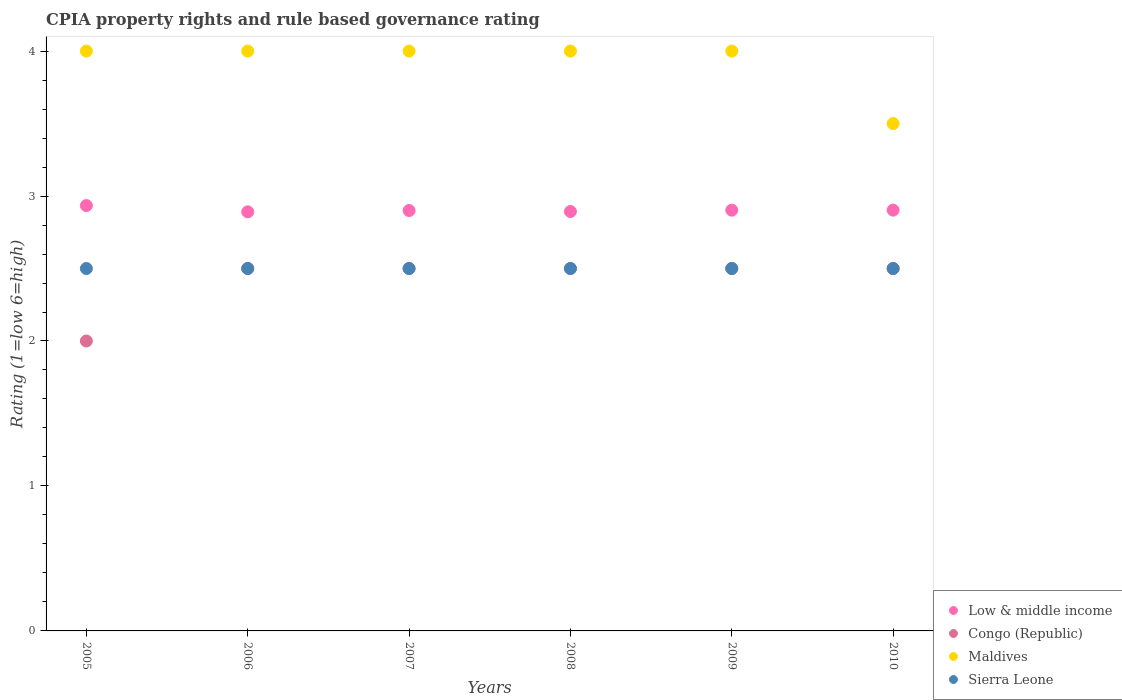How many different coloured dotlines are there?
Give a very brief answer. 4. Is the number of dotlines equal to the number of legend labels?
Provide a short and direct response. Yes. What is the CPIA rating in Sierra Leone in 2009?
Your response must be concise. 2.5. Across all years, what is the maximum CPIA rating in Low & middle income?
Your response must be concise. 2.93. Across all years, what is the minimum CPIA rating in Sierra Leone?
Provide a short and direct response. 2.5. In which year was the CPIA rating in Congo (Republic) maximum?
Your response must be concise. 2006. In which year was the CPIA rating in Low & middle income minimum?
Provide a succinct answer. 2006. What is the total CPIA rating in Low & middle income in the graph?
Make the answer very short. 17.42. What is the difference between the CPIA rating in Low & middle income in 2007 and that in 2008?
Provide a succinct answer. 0.01. What is the difference between the CPIA rating in Sierra Leone in 2009 and the CPIA rating in Maldives in 2008?
Keep it short and to the point. -1.5. What is the average CPIA rating in Congo (Republic) per year?
Your response must be concise. 2.42. In the year 2007, what is the difference between the CPIA rating in Sierra Leone and CPIA rating in Congo (Republic)?
Provide a short and direct response. 0. In how many years, is the CPIA rating in Low & middle income greater than 0.4?
Your answer should be very brief. 6. What is the ratio of the CPIA rating in Maldives in 2008 to that in 2010?
Your answer should be compact. 1.14. What is the difference between the highest and the second highest CPIA rating in Low & middle income?
Offer a terse response. 0.03. Is the sum of the CPIA rating in Maldives in 2006 and 2008 greater than the maximum CPIA rating in Low & middle income across all years?
Offer a very short reply. Yes. Is it the case that in every year, the sum of the CPIA rating in Low & middle income and CPIA rating in Congo (Republic)  is greater than the sum of CPIA rating in Maldives and CPIA rating in Sierra Leone?
Make the answer very short. No. Does the CPIA rating in Sierra Leone monotonically increase over the years?
Your answer should be compact. No. Is the CPIA rating in Maldives strictly less than the CPIA rating in Sierra Leone over the years?
Offer a terse response. No. How many dotlines are there?
Offer a very short reply. 4. What is the difference between two consecutive major ticks on the Y-axis?
Offer a very short reply. 1. Are the values on the major ticks of Y-axis written in scientific E-notation?
Provide a short and direct response. No. How many legend labels are there?
Provide a short and direct response. 4. What is the title of the graph?
Offer a very short reply. CPIA property rights and rule based governance rating. Does "Korea (Democratic)" appear as one of the legend labels in the graph?
Ensure brevity in your answer.  No. What is the Rating (1=low 6=high) of Low & middle income in 2005?
Make the answer very short. 2.93. What is the Rating (1=low 6=high) of Congo (Republic) in 2005?
Your answer should be very brief. 2. What is the Rating (1=low 6=high) of Low & middle income in 2006?
Your answer should be very brief. 2.89. What is the Rating (1=low 6=high) in Congo (Republic) in 2006?
Provide a succinct answer. 2.5. What is the Rating (1=low 6=high) in Sierra Leone in 2006?
Give a very brief answer. 2.5. What is the Rating (1=low 6=high) in Congo (Republic) in 2007?
Ensure brevity in your answer.  2.5. What is the Rating (1=low 6=high) in Maldives in 2007?
Your answer should be very brief. 4. What is the Rating (1=low 6=high) of Sierra Leone in 2007?
Provide a succinct answer. 2.5. What is the Rating (1=low 6=high) of Low & middle income in 2008?
Your answer should be compact. 2.89. What is the Rating (1=low 6=high) of Congo (Republic) in 2008?
Provide a succinct answer. 2.5. What is the Rating (1=low 6=high) of Maldives in 2008?
Offer a terse response. 4. What is the Rating (1=low 6=high) of Sierra Leone in 2008?
Ensure brevity in your answer.  2.5. What is the Rating (1=low 6=high) in Low & middle income in 2009?
Give a very brief answer. 2.9. What is the Rating (1=low 6=high) in Congo (Republic) in 2009?
Offer a terse response. 2.5. What is the Rating (1=low 6=high) in Low & middle income in 2010?
Provide a short and direct response. 2.9. What is the Rating (1=low 6=high) of Congo (Republic) in 2010?
Give a very brief answer. 2.5. What is the Rating (1=low 6=high) in Sierra Leone in 2010?
Give a very brief answer. 2.5. Across all years, what is the maximum Rating (1=low 6=high) of Low & middle income?
Provide a succinct answer. 2.93. Across all years, what is the maximum Rating (1=low 6=high) in Congo (Republic)?
Your answer should be compact. 2.5. Across all years, what is the maximum Rating (1=low 6=high) of Sierra Leone?
Your answer should be very brief. 2.5. Across all years, what is the minimum Rating (1=low 6=high) in Low & middle income?
Provide a short and direct response. 2.89. What is the total Rating (1=low 6=high) in Low & middle income in the graph?
Your response must be concise. 17.42. What is the total Rating (1=low 6=high) of Congo (Republic) in the graph?
Offer a very short reply. 14.5. What is the total Rating (1=low 6=high) of Sierra Leone in the graph?
Give a very brief answer. 15. What is the difference between the Rating (1=low 6=high) of Low & middle income in 2005 and that in 2006?
Your answer should be compact. 0.04. What is the difference between the Rating (1=low 6=high) of Congo (Republic) in 2005 and that in 2006?
Ensure brevity in your answer.  -0.5. What is the difference between the Rating (1=low 6=high) in Low & middle income in 2005 and that in 2007?
Ensure brevity in your answer.  0.03. What is the difference between the Rating (1=low 6=high) of Maldives in 2005 and that in 2007?
Offer a terse response. 0. What is the difference between the Rating (1=low 6=high) of Low & middle income in 2005 and that in 2008?
Provide a short and direct response. 0.04. What is the difference between the Rating (1=low 6=high) of Maldives in 2005 and that in 2008?
Provide a short and direct response. 0. What is the difference between the Rating (1=low 6=high) in Low & middle income in 2005 and that in 2009?
Your answer should be compact. 0.03. What is the difference between the Rating (1=low 6=high) of Maldives in 2005 and that in 2009?
Provide a short and direct response. 0. What is the difference between the Rating (1=low 6=high) in Low & middle income in 2005 and that in 2010?
Keep it short and to the point. 0.03. What is the difference between the Rating (1=low 6=high) in Sierra Leone in 2005 and that in 2010?
Your answer should be compact. 0. What is the difference between the Rating (1=low 6=high) of Low & middle income in 2006 and that in 2007?
Your answer should be very brief. -0.01. What is the difference between the Rating (1=low 6=high) in Sierra Leone in 2006 and that in 2007?
Provide a short and direct response. 0. What is the difference between the Rating (1=low 6=high) of Low & middle income in 2006 and that in 2008?
Your response must be concise. -0. What is the difference between the Rating (1=low 6=high) in Congo (Republic) in 2006 and that in 2008?
Your answer should be compact. 0. What is the difference between the Rating (1=low 6=high) of Low & middle income in 2006 and that in 2009?
Your answer should be very brief. -0.01. What is the difference between the Rating (1=low 6=high) in Congo (Republic) in 2006 and that in 2009?
Ensure brevity in your answer.  0. What is the difference between the Rating (1=low 6=high) in Low & middle income in 2006 and that in 2010?
Your answer should be very brief. -0.01. What is the difference between the Rating (1=low 6=high) in Low & middle income in 2007 and that in 2008?
Give a very brief answer. 0.01. What is the difference between the Rating (1=low 6=high) in Congo (Republic) in 2007 and that in 2008?
Offer a terse response. 0. What is the difference between the Rating (1=low 6=high) of Maldives in 2007 and that in 2008?
Give a very brief answer. 0. What is the difference between the Rating (1=low 6=high) of Sierra Leone in 2007 and that in 2008?
Your answer should be compact. 0. What is the difference between the Rating (1=low 6=high) in Low & middle income in 2007 and that in 2009?
Your answer should be compact. -0. What is the difference between the Rating (1=low 6=high) of Low & middle income in 2007 and that in 2010?
Make the answer very short. -0. What is the difference between the Rating (1=low 6=high) of Sierra Leone in 2007 and that in 2010?
Offer a terse response. 0. What is the difference between the Rating (1=low 6=high) of Low & middle income in 2008 and that in 2009?
Your answer should be compact. -0.01. What is the difference between the Rating (1=low 6=high) in Congo (Republic) in 2008 and that in 2009?
Make the answer very short. 0. What is the difference between the Rating (1=low 6=high) in Low & middle income in 2008 and that in 2010?
Your answer should be very brief. -0.01. What is the difference between the Rating (1=low 6=high) in Maldives in 2008 and that in 2010?
Make the answer very short. 0.5. What is the difference between the Rating (1=low 6=high) in Sierra Leone in 2008 and that in 2010?
Your answer should be compact. 0. What is the difference between the Rating (1=low 6=high) in Maldives in 2009 and that in 2010?
Offer a very short reply. 0.5. What is the difference between the Rating (1=low 6=high) in Low & middle income in 2005 and the Rating (1=low 6=high) in Congo (Republic) in 2006?
Give a very brief answer. 0.43. What is the difference between the Rating (1=low 6=high) of Low & middle income in 2005 and the Rating (1=low 6=high) of Maldives in 2006?
Keep it short and to the point. -1.07. What is the difference between the Rating (1=low 6=high) in Low & middle income in 2005 and the Rating (1=low 6=high) in Sierra Leone in 2006?
Your answer should be compact. 0.43. What is the difference between the Rating (1=low 6=high) of Maldives in 2005 and the Rating (1=low 6=high) of Sierra Leone in 2006?
Your answer should be compact. 1.5. What is the difference between the Rating (1=low 6=high) in Low & middle income in 2005 and the Rating (1=low 6=high) in Congo (Republic) in 2007?
Make the answer very short. 0.43. What is the difference between the Rating (1=low 6=high) in Low & middle income in 2005 and the Rating (1=low 6=high) in Maldives in 2007?
Offer a very short reply. -1.07. What is the difference between the Rating (1=low 6=high) in Low & middle income in 2005 and the Rating (1=low 6=high) in Sierra Leone in 2007?
Offer a very short reply. 0.43. What is the difference between the Rating (1=low 6=high) in Congo (Republic) in 2005 and the Rating (1=low 6=high) in Maldives in 2007?
Keep it short and to the point. -2. What is the difference between the Rating (1=low 6=high) of Congo (Republic) in 2005 and the Rating (1=low 6=high) of Sierra Leone in 2007?
Your response must be concise. -0.5. What is the difference between the Rating (1=low 6=high) of Low & middle income in 2005 and the Rating (1=low 6=high) of Congo (Republic) in 2008?
Make the answer very short. 0.43. What is the difference between the Rating (1=low 6=high) of Low & middle income in 2005 and the Rating (1=low 6=high) of Maldives in 2008?
Make the answer very short. -1.07. What is the difference between the Rating (1=low 6=high) of Low & middle income in 2005 and the Rating (1=low 6=high) of Sierra Leone in 2008?
Offer a very short reply. 0.43. What is the difference between the Rating (1=low 6=high) in Congo (Republic) in 2005 and the Rating (1=low 6=high) in Sierra Leone in 2008?
Your response must be concise. -0.5. What is the difference between the Rating (1=low 6=high) of Maldives in 2005 and the Rating (1=low 6=high) of Sierra Leone in 2008?
Make the answer very short. 1.5. What is the difference between the Rating (1=low 6=high) of Low & middle income in 2005 and the Rating (1=low 6=high) of Congo (Republic) in 2009?
Offer a very short reply. 0.43. What is the difference between the Rating (1=low 6=high) in Low & middle income in 2005 and the Rating (1=low 6=high) in Maldives in 2009?
Offer a terse response. -1.07. What is the difference between the Rating (1=low 6=high) of Low & middle income in 2005 and the Rating (1=low 6=high) of Sierra Leone in 2009?
Make the answer very short. 0.43. What is the difference between the Rating (1=low 6=high) in Congo (Republic) in 2005 and the Rating (1=low 6=high) in Sierra Leone in 2009?
Offer a very short reply. -0.5. What is the difference between the Rating (1=low 6=high) of Low & middle income in 2005 and the Rating (1=low 6=high) of Congo (Republic) in 2010?
Make the answer very short. 0.43. What is the difference between the Rating (1=low 6=high) of Low & middle income in 2005 and the Rating (1=low 6=high) of Maldives in 2010?
Make the answer very short. -0.57. What is the difference between the Rating (1=low 6=high) of Low & middle income in 2005 and the Rating (1=low 6=high) of Sierra Leone in 2010?
Provide a succinct answer. 0.43. What is the difference between the Rating (1=low 6=high) in Congo (Republic) in 2005 and the Rating (1=low 6=high) in Maldives in 2010?
Provide a succinct answer. -1.5. What is the difference between the Rating (1=low 6=high) of Congo (Republic) in 2005 and the Rating (1=low 6=high) of Sierra Leone in 2010?
Offer a terse response. -0.5. What is the difference between the Rating (1=low 6=high) of Maldives in 2005 and the Rating (1=low 6=high) of Sierra Leone in 2010?
Make the answer very short. 1.5. What is the difference between the Rating (1=low 6=high) of Low & middle income in 2006 and the Rating (1=low 6=high) of Congo (Republic) in 2007?
Make the answer very short. 0.39. What is the difference between the Rating (1=low 6=high) in Low & middle income in 2006 and the Rating (1=low 6=high) in Maldives in 2007?
Keep it short and to the point. -1.11. What is the difference between the Rating (1=low 6=high) in Low & middle income in 2006 and the Rating (1=low 6=high) in Sierra Leone in 2007?
Your answer should be compact. 0.39. What is the difference between the Rating (1=low 6=high) of Congo (Republic) in 2006 and the Rating (1=low 6=high) of Sierra Leone in 2007?
Give a very brief answer. 0. What is the difference between the Rating (1=low 6=high) in Maldives in 2006 and the Rating (1=low 6=high) in Sierra Leone in 2007?
Ensure brevity in your answer.  1.5. What is the difference between the Rating (1=low 6=high) in Low & middle income in 2006 and the Rating (1=low 6=high) in Congo (Republic) in 2008?
Offer a very short reply. 0.39. What is the difference between the Rating (1=low 6=high) in Low & middle income in 2006 and the Rating (1=low 6=high) in Maldives in 2008?
Provide a short and direct response. -1.11. What is the difference between the Rating (1=low 6=high) in Low & middle income in 2006 and the Rating (1=low 6=high) in Sierra Leone in 2008?
Ensure brevity in your answer.  0.39. What is the difference between the Rating (1=low 6=high) in Congo (Republic) in 2006 and the Rating (1=low 6=high) in Maldives in 2008?
Offer a terse response. -1.5. What is the difference between the Rating (1=low 6=high) of Maldives in 2006 and the Rating (1=low 6=high) of Sierra Leone in 2008?
Keep it short and to the point. 1.5. What is the difference between the Rating (1=low 6=high) of Low & middle income in 2006 and the Rating (1=low 6=high) of Congo (Republic) in 2009?
Provide a succinct answer. 0.39. What is the difference between the Rating (1=low 6=high) of Low & middle income in 2006 and the Rating (1=low 6=high) of Maldives in 2009?
Make the answer very short. -1.11. What is the difference between the Rating (1=low 6=high) in Low & middle income in 2006 and the Rating (1=low 6=high) in Sierra Leone in 2009?
Your response must be concise. 0.39. What is the difference between the Rating (1=low 6=high) in Congo (Republic) in 2006 and the Rating (1=low 6=high) in Sierra Leone in 2009?
Your answer should be compact. 0. What is the difference between the Rating (1=low 6=high) of Maldives in 2006 and the Rating (1=low 6=high) of Sierra Leone in 2009?
Provide a short and direct response. 1.5. What is the difference between the Rating (1=low 6=high) in Low & middle income in 2006 and the Rating (1=low 6=high) in Congo (Republic) in 2010?
Your response must be concise. 0.39. What is the difference between the Rating (1=low 6=high) in Low & middle income in 2006 and the Rating (1=low 6=high) in Maldives in 2010?
Provide a succinct answer. -0.61. What is the difference between the Rating (1=low 6=high) in Low & middle income in 2006 and the Rating (1=low 6=high) in Sierra Leone in 2010?
Provide a succinct answer. 0.39. What is the difference between the Rating (1=low 6=high) of Congo (Republic) in 2006 and the Rating (1=low 6=high) of Sierra Leone in 2010?
Provide a short and direct response. 0. What is the difference between the Rating (1=low 6=high) in Low & middle income in 2007 and the Rating (1=low 6=high) in Maldives in 2008?
Provide a short and direct response. -1.1. What is the difference between the Rating (1=low 6=high) in Congo (Republic) in 2007 and the Rating (1=low 6=high) in Sierra Leone in 2008?
Give a very brief answer. 0. What is the difference between the Rating (1=low 6=high) of Low & middle income in 2007 and the Rating (1=low 6=high) of Congo (Republic) in 2009?
Offer a terse response. 0.4. What is the difference between the Rating (1=low 6=high) in Low & middle income in 2007 and the Rating (1=low 6=high) in Sierra Leone in 2009?
Keep it short and to the point. 0.4. What is the difference between the Rating (1=low 6=high) of Congo (Republic) in 2007 and the Rating (1=low 6=high) of Maldives in 2009?
Keep it short and to the point. -1.5. What is the difference between the Rating (1=low 6=high) of Congo (Republic) in 2007 and the Rating (1=low 6=high) of Sierra Leone in 2009?
Keep it short and to the point. 0. What is the difference between the Rating (1=low 6=high) of Maldives in 2007 and the Rating (1=low 6=high) of Sierra Leone in 2009?
Ensure brevity in your answer.  1.5. What is the difference between the Rating (1=low 6=high) in Low & middle income in 2007 and the Rating (1=low 6=high) in Congo (Republic) in 2010?
Your answer should be compact. 0.4. What is the difference between the Rating (1=low 6=high) in Low & middle income in 2007 and the Rating (1=low 6=high) in Maldives in 2010?
Make the answer very short. -0.6. What is the difference between the Rating (1=low 6=high) of Congo (Republic) in 2007 and the Rating (1=low 6=high) of Sierra Leone in 2010?
Give a very brief answer. 0. What is the difference between the Rating (1=low 6=high) of Maldives in 2007 and the Rating (1=low 6=high) of Sierra Leone in 2010?
Keep it short and to the point. 1.5. What is the difference between the Rating (1=low 6=high) of Low & middle income in 2008 and the Rating (1=low 6=high) of Congo (Republic) in 2009?
Give a very brief answer. 0.39. What is the difference between the Rating (1=low 6=high) in Low & middle income in 2008 and the Rating (1=low 6=high) in Maldives in 2009?
Your answer should be very brief. -1.11. What is the difference between the Rating (1=low 6=high) in Low & middle income in 2008 and the Rating (1=low 6=high) in Sierra Leone in 2009?
Ensure brevity in your answer.  0.39. What is the difference between the Rating (1=low 6=high) in Congo (Republic) in 2008 and the Rating (1=low 6=high) in Maldives in 2009?
Ensure brevity in your answer.  -1.5. What is the difference between the Rating (1=low 6=high) of Congo (Republic) in 2008 and the Rating (1=low 6=high) of Sierra Leone in 2009?
Offer a very short reply. 0. What is the difference between the Rating (1=low 6=high) in Maldives in 2008 and the Rating (1=low 6=high) in Sierra Leone in 2009?
Keep it short and to the point. 1.5. What is the difference between the Rating (1=low 6=high) in Low & middle income in 2008 and the Rating (1=low 6=high) in Congo (Republic) in 2010?
Your answer should be compact. 0.39. What is the difference between the Rating (1=low 6=high) in Low & middle income in 2008 and the Rating (1=low 6=high) in Maldives in 2010?
Keep it short and to the point. -0.61. What is the difference between the Rating (1=low 6=high) in Low & middle income in 2008 and the Rating (1=low 6=high) in Sierra Leone in 2010?
Provide a short and direct response. 0.39. What is the difference between the Rating (1=low 6=high) of Low & middle income in 2009 and the Rating (1=low 6=high) of Congo (Republic) in 2010?
Offer a terse response. 0.4. What is the difference between the Rating (1=low 6=high) of Low & middle income in 2009 and the Rating (1=low 6=high) of Maldives in 2010?
Make the answer very short. -0.6. What is the difference between the Rating (1=low 6=high) in Low & middle income in 2009 and the Rating (1=low 6=high) in Sierra Leone in 2010?
Make the answer very short. 0.4. What is the difference between the Rating (1=low 6=high) of Congo (Republic) in 2009 and the Rating (1=low 6=high) of Sierra Leone in 2010?
Provide a short and direct response. 0. What is the average Rating (1=low 6=high) in Low & middle income per year?
Your answer should be compact. 2.9. What is the average Rating (1=low 6=high) of Congo (Republic) per year?
Provide a short and direct response. 2.42. What is the average Rating (1=low 6=high) of Maldives per year?
Give a very brief answer. 3.92. What is the average Rating (1=low 6=high) in Sierra Leone per year?
Your response must be concise. 2.5. In the year 2005, what is the difference between the Rating (1=low 6=high) of Low & middle income and Rating (1=low 6=high) of Congo (Republic)?
Offer a very short reply. 0.93. In the year 2005, what is the difference between the Rating (1=low 6=high) in Low & middle income and Rating (1=low 6=high) in Maldives?
Your response must be concise. -1.07. In the year 2005, what is the difference between the Rating (1=low 6=high) in Low & middle income and Rating (1=low 6=high) in Sierra Leone?
Your response must be concise. 0.43. In the year 2005, what is the difference between the Rating (1=low 6=high) of Congo (Republic) and Rating (1=low 6=high) of Maldives?
Give a very brief answer. -2. In the year 2006, what is the difference between the Rating (1=low 6=high) of Low & middle income and Rating (1=low 6=high) of Congo (Republic)?
Provide a short and direct response. 0.39. In the year 2006, what is the difference between the Rating (1=low 6=high) of Low & middle income and Rating (1=low 6=high) of Maldives?
Make the answer very short. -1.11. In the year 2006, what is the difference between the Rating (1=low 6=high) in Low & middle income and Rating (1=low 6=high) in Sierra Leone?
Keep it short and to the point. 0.39. In the year 2007, what is the difference between the Rating (1=low 6=high) in Low & middle income and Rating (1=low 6=high) in Congo (Republic)?
Ensure brevity in your answer.  0.4. In the year 2007, what is the difference between the Rating (1=low 6=high) of Low & middle income and Rating (1=low 6=high) of Maldives?
Give a very brief answer. -1.1. In the year 2007, what is the difference between the Rating (1=low 6=high) of Low & middle income and Rating (1=low 6=high) of Sierra Leone?
Ensure brevity in your answer.  0.4. In the year 2007, what is the difference between the Rating (1=low 6=high) of Maldives and Rating (1=low 6=high) of Sierra Leone?
Keep it short and to the point. 1.5. In the year 2008, what is the difference between the Rating (1=low 6=high) in Low & middle income and Rating (1=low 6=high) in Congo (Republic)?
Offer a terse response. 0.39. In the year 2008, what is the difference between the Rating (1=low 6=high) in Low & middle income and Rating (1=low 6=high) in Maldives?
Give a very brief answer. -1.11. In the year 2008, what is the difference between the Rating (1=low 6=high) of Low & middle income and Rating (1=low 6=high) of Sierra Leone?
Provide a short and direct response. 0.39. In the year 2008, what is the difference between the Rating (1=low 6=high) of Congo (Republic) and Rating (1=low 6=high) of Maldives?
Give a very brief answer. -1.5. In the year 2009, what is the difference between the Rating (1=low 6=high) in Low & middle income and Rating (1=low 6=high) in Congo (Republic)?
Your answer should be compact. 0.4. In the year 2009, what is the difference between the Rating (1=low 6=high) of Low & middle income and Rating (1=low 6=high) of Maldives?
Keep it short and to the point. -1.1. In the year 2009, what is the difference between the Rating (1=low 6=high) of Low & middle income and Rating (1=low 6=high) of Sierra Leone?
Your response must be concise. 0.4. In the year 2009, what is the difference between the Rating (1=low 6=high) in Maldives and Rating (1=low 6=high) in Sierra Leone?
Give a very brief answer. 1.5. In the year 2010, what is the difference between the Rating (1=low 6=high) of Low & middle income and Rating (1=low 6=high) of Congo (Republic)?
Offer a terse response. 0.4. In the year 2010, what is the difference between the Rating (1=low 6=high) of Low & middle income and Rating (1=low 6=high) of Maldives?
Ensure brevity in your answer.  -0.6. In the year 2010, what is the difference between the Rating (1=low 6=high) of Low & middle income and Rating (1=low 6=high) of Sierra Leone?
Keep it short and to the point. 0.4. What is the ratio of the Rating (1=low 6=high) of Low & middle income in 2005 to that in 2006?
Provide a short and direct response. 1.01. What is the ratio of the Rating (1=low 6=high) in Congo (Republic) in 2005 to that in 2006?
Provide a succinct answer. 0.8. What is the ratio of the Rating (1=low 6=high) of Low & middle income in 2005 to that in 2007?
Keep it short and to the point. 1.01. What is the ratio of the Rating (1=low 6=high) of Congo (Republic) in 2005 to that in 2007?
Provide a short and direct response. 0.8. What is the ratio of the Rating (1=low 6=high) of Maldives in 2005 to that in 2007?
Provide a short and direct response. 1. What is the ratio of the Rating (1=low 6=high) of Sierra Leone in 2005 to that in 2007?
Your answer should be compact. 1. What is the ratio of the Rating (1=low 6=high) of Low & middle income in 2005 to that in 2008?
Offer a terse response. 1.01. What is the ratio of the Rating (1=low 6=high) in Congo (Republic) in 2005 to that in 2008?
Offer a very short reply. 0.8. What is the ratio of the Rating (1=low 6=high) in Maldives in 2005 to that in 2008?
Keep it short and to the point. 1. What is the ratio of the Rating (1=low 6=high) of Sierra Leone in 2005 to that in 2008?
Your answer should be compact. 1. What is the ratio of the Rating (1=low 6=high) in Low & middle income in 2005 to that in 2009?
Your answer should be very brief. 1.01. What is the ratio of the Rating (1=low 6=high) of Congo (Republic) in 2005 to that in 2009?
Your response must be concise. 0.8. What is the ratio of the Rating (1=low 6=high) in Maldives in 2005 to that in 2009?
Your response must be concise. 1. What is the ratio of the Rating (1=low 6=high) in Sierra Leone in 2005 to that in 2009?
Your answer should be very brief. 1. What is the ratio of the Rating (1=low 6=high) in Low & middle income in 2005 to that in 2010?
Your answer should be very brief. 1.01. What is the ratio of the Rating (1=low 6=high) in Maldives in 2005 to that in 2010?
Keep it short and to the point. 1.14. What is the ratio of the Rating (1=low 6=high) in Low & middle income in 2006 to that in 2007?
Make the answer very short. 1. What is the ratio of the Rating (1=low 6=high) of Low & middle income in 2006 to that in 2008?
Your answer should be compact. 1. What is the ratio of the Rating (1=low 6=high) in Congo (Republic) in 2006 to that in 2008?
Keep it short and to the point. 1. What is the ratio of the Rating (1=low 6=high) of Maldives in 2006 to that in 2008?
Your answer should be compact. 1. What is the ratio of the Rating (1=low 6=high) of Sierra Leone in 2006 to that in 2008?
Provide a succinct answer. 1. What is the ratio of the Rating (1=low 6=high) of Low & middle income in 2006 to that in 2009?
Give a very brief answer. 1. What is the ratio of the Rating (1=low 6=high) in Maldives in 2006 to that in 2009?
Ensure brevity in your answer.  1. What is the ratio of the Rating (1=low 6=high) of Congo (Republic) in 2006 to that in 2010?
Offer a terse response. 1. What is the ratio of the Rating (1=low 6=high) of Maldives in 2006 to that in 2010?
Offer a very short reply. 1.14. What is the ratio of the Rating (1=low 6=high) in Sierra Leone in 2006 to that in 2010?
Keep it short and to the point. 1. What is the ratio of the Rating (1=low 6=high) of Low & middle income in 2007 to that in 2008?
Provide a short and direct response. 1. What is the ratio of the Rating (1=low 6=high) of Maldives in 2007 to that in 2008?
Ensure brevity in your answer.  1. What is the ratio of the Rating (1=low 6=high) in Sierra Leone in 2007 to that in 2008?
Give a very brief answer. 1. What is the ratio of the Rating (1=low 6=high) in Low & middle income in 2007 to that in 2009?
Keep it short and to the point. 1. What is the ratio of the Rating (1=low 6=high) of Congo (Republic) in 2007 to that in 2009?
Make the answer very short. 1. What is the ratio of the Rating (1=low 6=high) in Sierra Leone in 2007 to that in 2009?
Your response must be concise. 1. What is the ratio of the Rating (1=low 6=high) of Low & middle income in 2007 to that in 2010?
Keep it short and to the point. 1. What is the ratio of the Rating (1=low 6=high) in Sierra Leone in 2007 to that in 2010?
Ensure brevity in your answer.  1. What is the ratio of the Rating (1=low 6=high) of Congo (Republic) in 2008 to that in 2009?
Your response must be concise. 1. What is the ratio of the Rating (1=low 6=high) in Low & middle income in 2008 to that in 2010?
Ensure brevity in your answer.  1. What is the ratio of the Rating (1=low 6=high) in Sierra Leone in 2008 to that in 2010?
Give a very brief answer. 1. What is the ratio of the Rating (1=low 6=high) of Low & middle income in 2009 to that in 2010?
Your answer should be compact. 1. What is the ratio of the Rating (1=low 6=high) of Maldives in 2009 to that in 2010?
Offer a very short reply. 1.14. What is the difference between the highest and the second highest Rating (1=low 6=high) of Low & middle income?
Ensure brevity in your answer.  0.03. What is the difference between the highest and the second highest Rating (1=low 6=high) of Congo (Republic)?
Offer a very short reply. 0. What is the difference between the highest and the lowest Rating (1=low 6=high) in Low & middle income?
Offer a very short reply. 0.04. What is the difference between the highest and the lowest Rating (1=low 6=high) of Sierra Leone?
Keep it short and to the point. 0. 